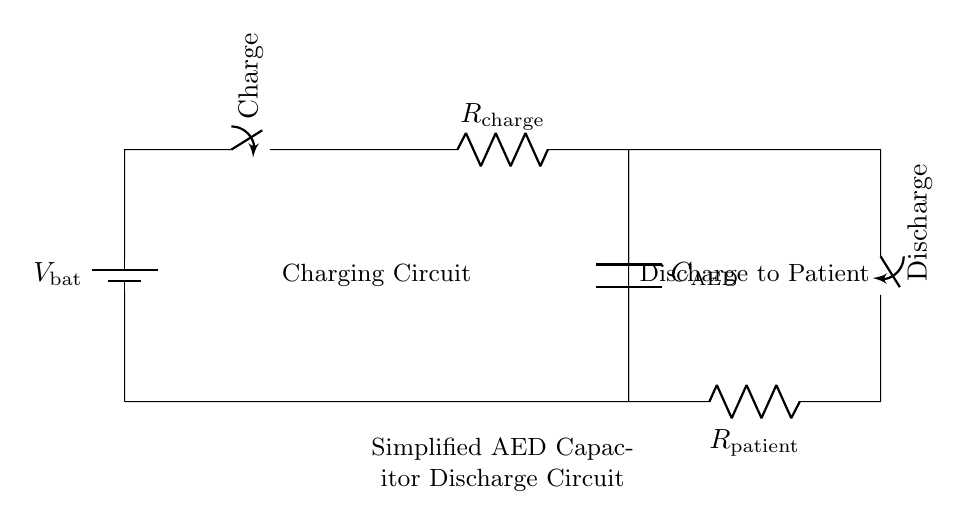What is the voltage source in this circuit? The voltage source is a battery denoted as V bat, providing the supply voltage for charging the capacitor.
Answer: V bat What type of switch is used during the charging phase? The switch labeled "Charge" is a mechanical switch that allows current to flow to the capacitor for charging.
Answer: Charge What component is responsible for energy storage in this circuit? The component responsible for energy storage is the capacitor, labeled as C AED, which stores energy when charged.
Answer: C AED What is the purpose of R patient in the circuit? R patient represents the resistance of the patient and is used to limit the current during the discharge phase to ensure safe delivery of energy.
Answer: R patient How does the discharge switch affect the flow of current? The discharge switch, when closed, allows the stored energy in the capacitor to flow through R patient to the patient, enabling defibrillation.
Answer: It allows current flow What happens to the voltage across C AED during discharge? During discharge, the voltage across C AED decreases as it releases its stored energy to R patient, causing a gradual drop until the capacitor is fully discharged.
Answer: Voltage decreases 